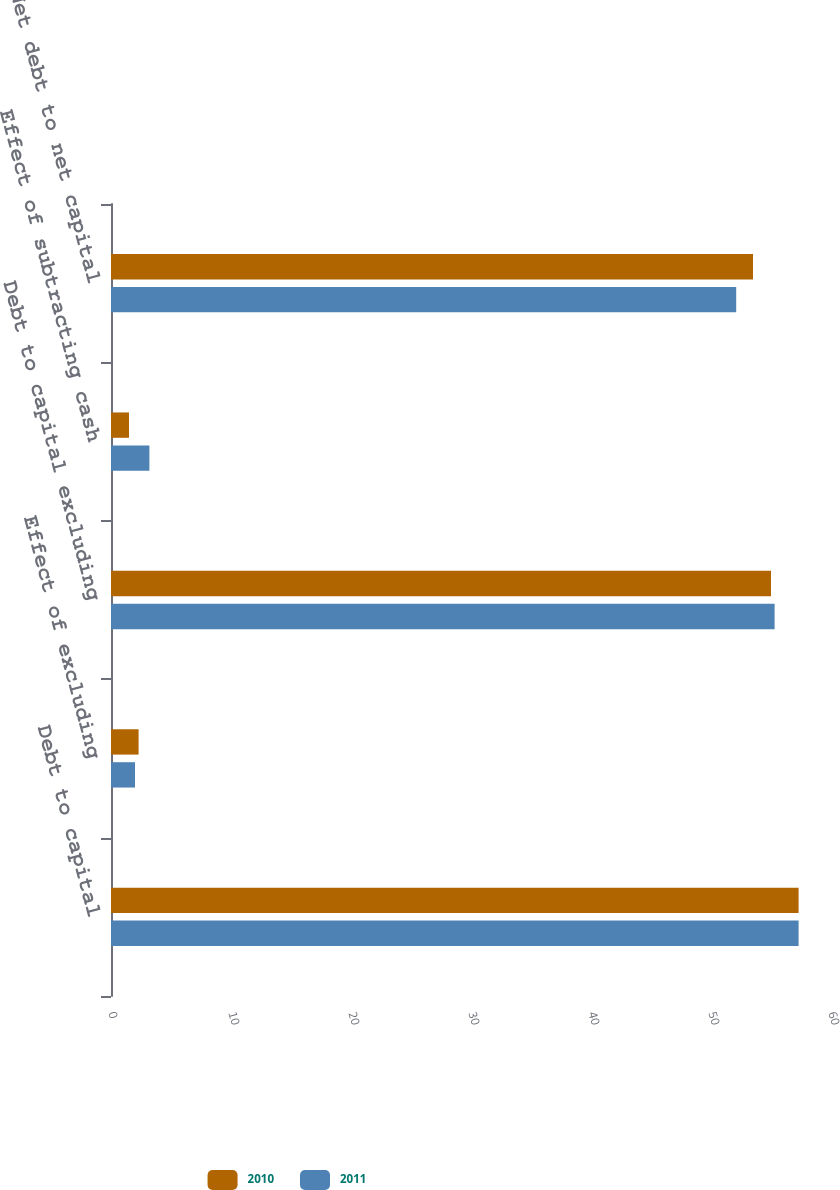<chart> <loc_0><loc_0><loc_500><loc_500><stacked_bar_chart><ecel><fcel>Debt to capital<fcel>Effect of excluding<fcel>Debt to capital excluding<fcel>Effect of subtracting cash<fcel>Net debt to net capital<nl><fcel>2010<fcel>57.3<fcel>2.3<fcel>55<fcel>1.5<fcel>53.5<nl><fcel>2011<fcel>57.3<fcel>2<fcel>55.3<fcel>3.2<fcel>52.1<nl></chart> 